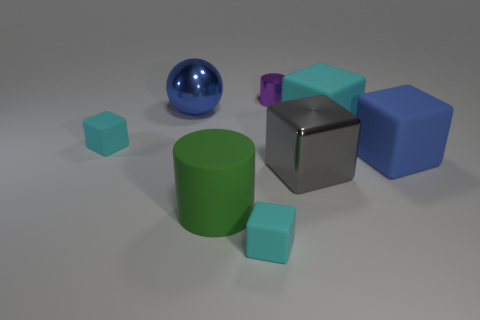Subtract all large shiny blocks. How many blocks are left? 4 Add 2 blue cubes. How many objects exist? 10 Subtract 3 cubes. How many cubes are left? 2 Subtract all blue cubes. How many cubes are left? 4 Subtract all blocks. How many objects are left? 3 Subtract all big blocks. Subtract all metal cubes. How many objects are left? 4 Add 8 purple metallic cylinders. How many purple metallic cylinders are left? 9 Add 4 rubber objects. How many rubber objects exist? 9 Subtract 1 blue balls. How many objects are left? 7 Subtract all gray cubes. Subtract all cyan cylinders. How many cubes are left? 4 